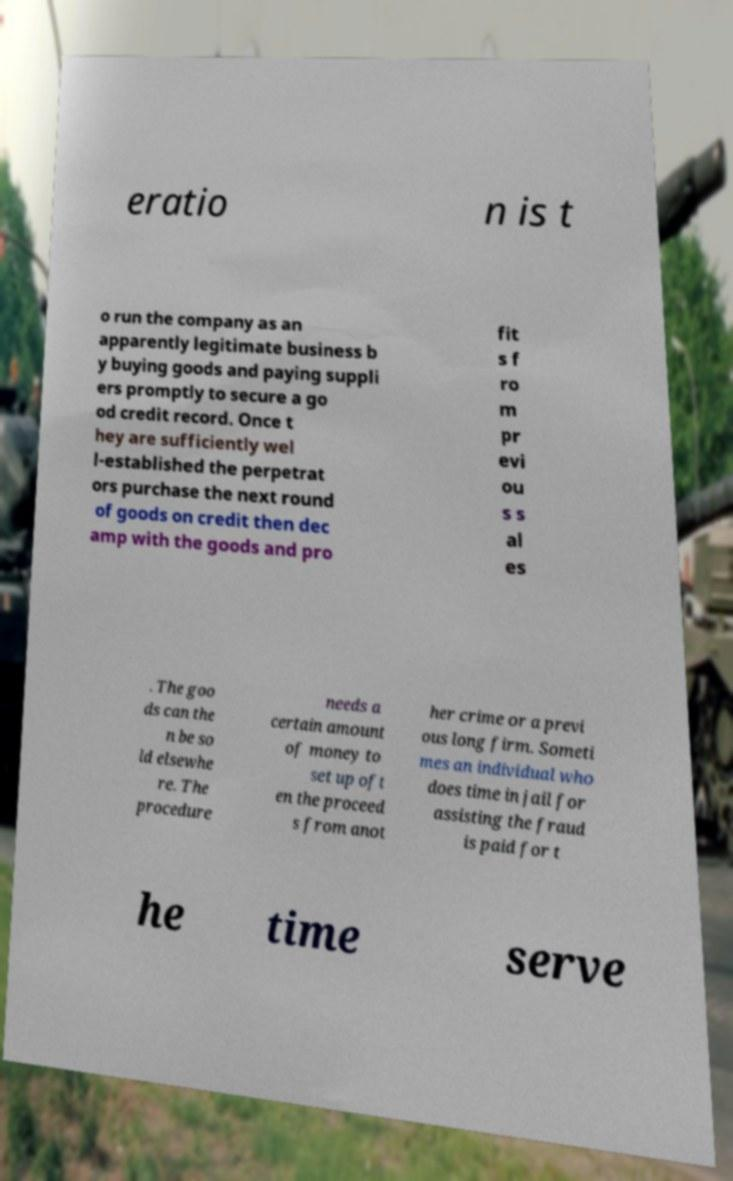For documentation purposes, I need the text within this image transcribed. Could you provide that? eratio n is t o run the company as an apparently legitimate business b y buying goods and paying suppli ers promptly to secure a go od credit record. Once t hey are sufficiently wel l-established the perpetrat ors purchase the next round of goods on credit then dec amp with the goods and pro fit s f ro m pr evi ou s s al es . The goo ds can the n be so ld elsewhe re. The procedure needs a certain amount of money to set up oft en the proceed s from anot her crime or a previ ous long firm. Someti mes an individual who does time in jail for assisting the fraud is paid for t he time serve 